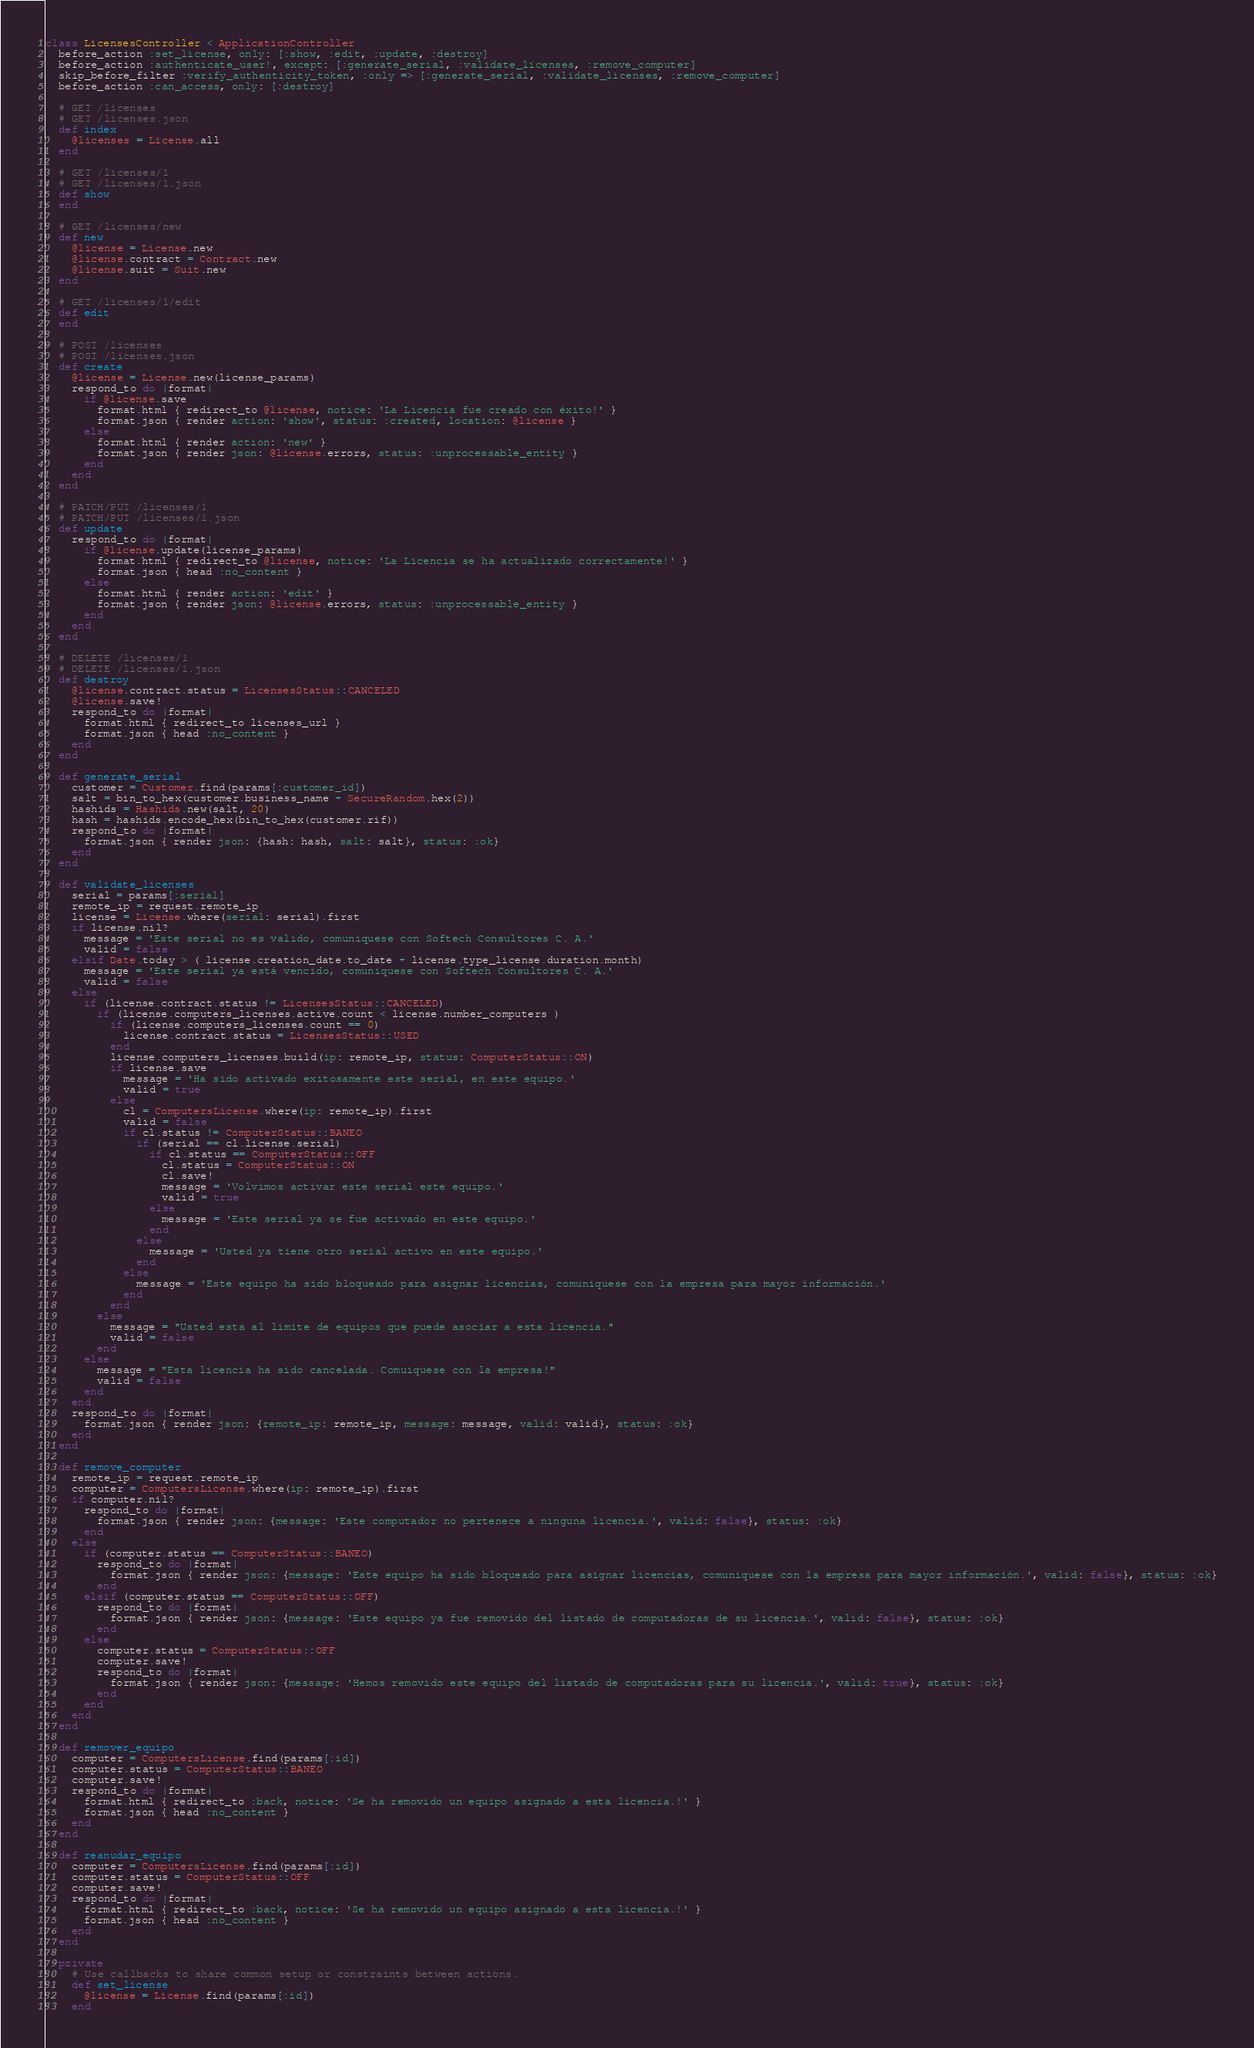<code> <loc_0><loc_0><loc_500><loc_500><_Ruby_>class LicensesController < ApplicationController
  before_action :set_license, only: [:show, :edit, :update, :destroy]
  before_action :authenticate_user!, except: [:generate_serial, :validate_licenses, :remove_computer]
  skip_before_filter :verify_authenticity_token, :only => [:generate_serial, :validate_licenses, :remove_computer]
  before_action :can_access, only: [:destroy]

  # GET /licenses
  # GET /licenses.json
  def index
    @licenses = License.all
  end

  # GET /licenses/1
  # GET /licenses/1.json
  def show
  end

  # GET /licenses/new
  def new
    @license = License.new
    @license.contract = Contract.new
    @license.suit = Suit.new
  end

  # GET /licenses/1/edit
  def edit
  end

  # POST /licenses
  # POST /licenses.json
  def create
    @license = License.new(license_params)
    respond_to do |format|
      if @license.save
        format.html { redirect_to @license, notice: 'La Licencia fue creado con éxito!' }
        format.json { render action: 'show', status: :created, location: @license }
      else
        format.html { render action: 'new' }
        format.json { render json: @license.errors, status: :unprocessable_entity }
      end
    end
  end

  # PATCH/PUT /licenses/1
  # PATCH/PUT /licenses/1.json
  def update
    respond_to do |format|
      if @license.update(license_params)
        format.html { redirect_to @license, notice: 'La Licencia se ha actualizado correctamente!' }
        format.json { head :no_content }
      else
        format.html { render action: 'edit' }
        format.json { render json: @license.errors, status: :unprocessable_entity }
      end
    end
  end

  # DELETE /licenses/1
  # DELETE /licenses/1.json
  def destroy
    @license.contract.status = LicensesStatus::CANCELED
    @license.save!
    respond_to do |format|
      format.html { redirect_to licenses_url }
      format.json { head :no_content }
    end
  end

  def generate_serial
    customer = Customer.find(params[:customer_id])
    salt = bin_to_hex(customer.business_name + SecureRandom.hex(2))
    hashids = Hashids.new(salt, 20)
    hash = hashids.encode_hex(bin_to_hex(customer.rif))
    respond_to do |format|
      format.json { render json: {hash: hash, salt: salt}, status: :ok}
    end
  end

  def validate_licenses
    serial = params[:serial]
    remote_ip = request.remote_ip
    license = License.where(serial: serial).first
    if license.nil?
      message = 'Este serial no es valido, comuniquese con Softech Consultores C. A.'
      valid = false
    elsif Date.today > ( license.creation_date.to_date + license.type_license.duration.month)
      message = 'Este serial ya está vencido, comuniquese con Softech Consultores C. A.'
      valid = false
    else
      if (license.contract.status != LicensesStatus::CANCELED)
        if (license.computers_licenses.active.count < license.number_computers )
          if (license.computers_licenses.count == 0)
            license.contract.status = LicensesStatus::USED
          end
          license.computers_licenses.build(ip: remote_ip, status: ComputerStatus::ON)
          if license.save
            message = 'Ha sido activado exitosamente este serial, en este equipo.'
            valid = true
          else
            cl = ComputersLicense.where(ip: remote_ip).first
            valid = false
            if cl.status != ComputerStatus::BANEO
              if (serial == cl.license.serial)
                if cl.status == ComputerStatus::OFF
                  cl.status = ComputerStatus::ON
                  cl.save!
                  message = 'Volvimos activar este serial este equipo.'
                  valid = true
                else
                  message = 'Este serial ya se fue activado en este equipo.'
                end
              else
                message = 'Usted ya tiene otro serial activo en este equipo.'
              end
            else
              message = 'Este equipo ha sido bloqueado para asignar licencias, comuniquese con la empresa para mayor información.'
            end
          end
        else
          message = "Usted esta al limite de equipos que puede asociar a esta licencia."
          valid = false
        end
      else
        message = "Esta licencia ha sido cancelada. Comuiquese con la empresa!"
        valid = false
      end
    end
    respond_to do |format|
      format.json { render json: {remote_ip: remote_ip, message: message, valid: valid}, status: :ok}
    end
  end

  def remove_computer
    remote_ip = request.remote_ip
    computer = ComputersLicense.where(ip: remote_ip).first
    if computer.nil?
      respond_to do |format|
        format.json { render json: {message: 'Este computador no pertenece a ninguna licencia.', valid: false}, status: :ok}
      end
    else
      if (computer.status == ComputerStatus::BANEO)
        respond_to do |format|
          format.json { render json: {message: 'Este equipo ha sido bloqueado para asignar licencias, comuniquese con la empresa para mayor información.', valid: false}, status: :ok}
        end
      elsif (computer.status == ComputerStatus::OFF)
        respond_to do |format|
          format.json { render json: {message: 'Este equipo ya fue removido del listado de computadoras de su licencia.', valid: false}, status: :ok}
        end
      else
        computer.status = ComputerStatus::OFF
        computer.save!
        respond_to do |format|
          format.json { render json: {message: 'Hemos removido este equipo del listado de computadoras para su licencia.', valid: true}, status: :ok}
        end
      end
    end
  end

  def remover_equipo
    computer = ComputersLicense.find(params[:id])
    computer.status = ComputerStatus::BANEO
    computer.save!
    respond_to do |format|
      format.html { redirect_to :back, notice: 'Se ha removido un equipo asignado a esta licencia.!' }
      format.json { head :no_content }
    end
  end

  def reanudar_equipo
    computer = ComputersLicense.find(params[:id])
    computer.status = ComputerStatus::OFF
    computer.save!
    respond_to do |format|
      format.html { redirect_to :back, notice: 'Se ha removido un equipo asignado a esta licencia.!' }
      format.json { head :no_content }
    end
  end

  private
    # Use callbacks to share common setup or constraints between actions.
    def set_license
      @license = License.find(params[:id])
    end
</code> 